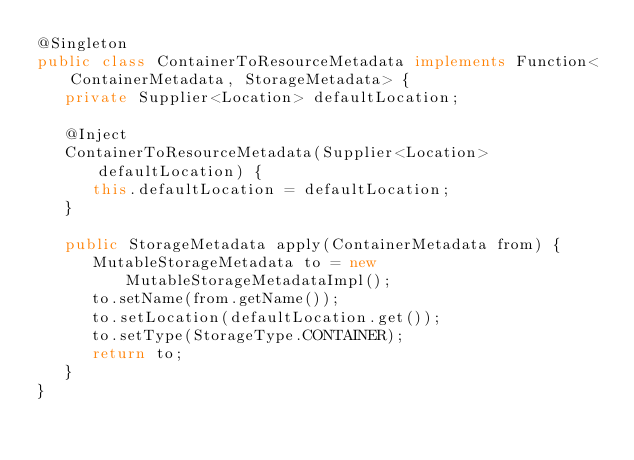<code> <loc_0><loc_0><loc_500><loc_500><_Java_>@Singleton
public class ContainerToResourceMetadata implements Function<ContainerMetadata, StorageMetadata> {
   private Supplier<Location> defaultLocation;

   @Inject
   ContainerToResourceMetadata(Supplier<Location> defaultLocation) {
      this.defaultLocation = defaultLocation;
   }

   public StorageMetadata apply(ContainerMetadata from) {
      MutableStorageMetadata to = new MutableStorageMetadataImpl();
      to.setName(from.getName());
      to.setLocation(defaultLocation.get());
      to.setType(StorageType.CONTAINER);
      return to;
   }
}
</code> 